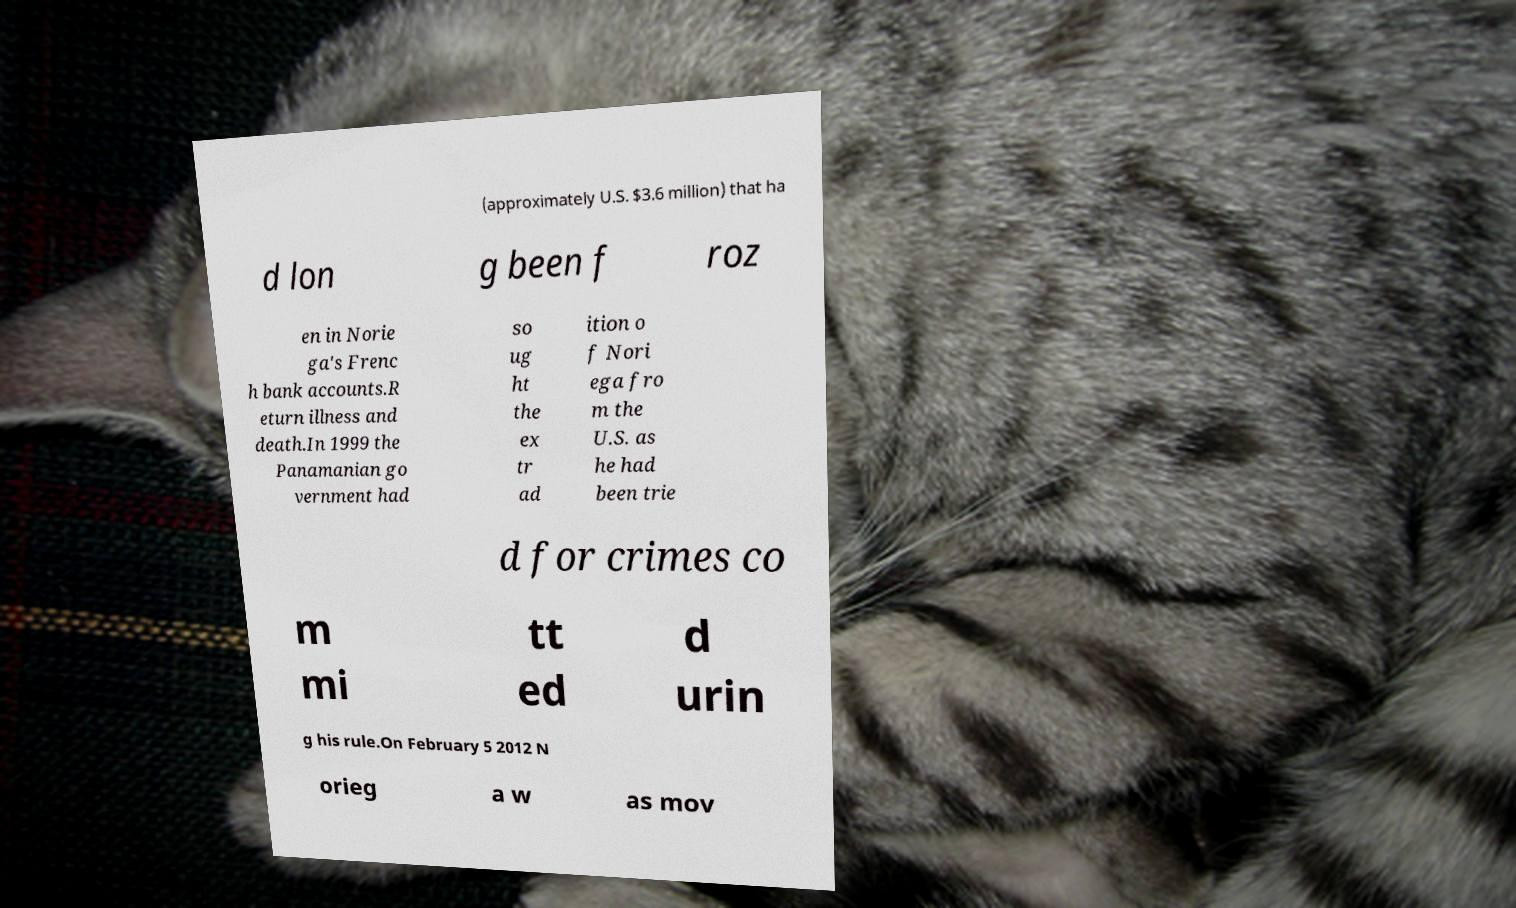What messages or text are displayed in this image? I need them in a readable, typed format. (approximately U.S. $3.6 million) that ha d lon g been f roz en in Norie ga's Frenc h bank accounts.R eturn illness and death.In 1999 the Panamanian go vernment had so ug ht the ex tr ad ition o f Nori ega fro m the U.S. as he had been trie d for crimes co m mi tt ed d urin g his rule.On February 5 2012 N orieg a w as mov 